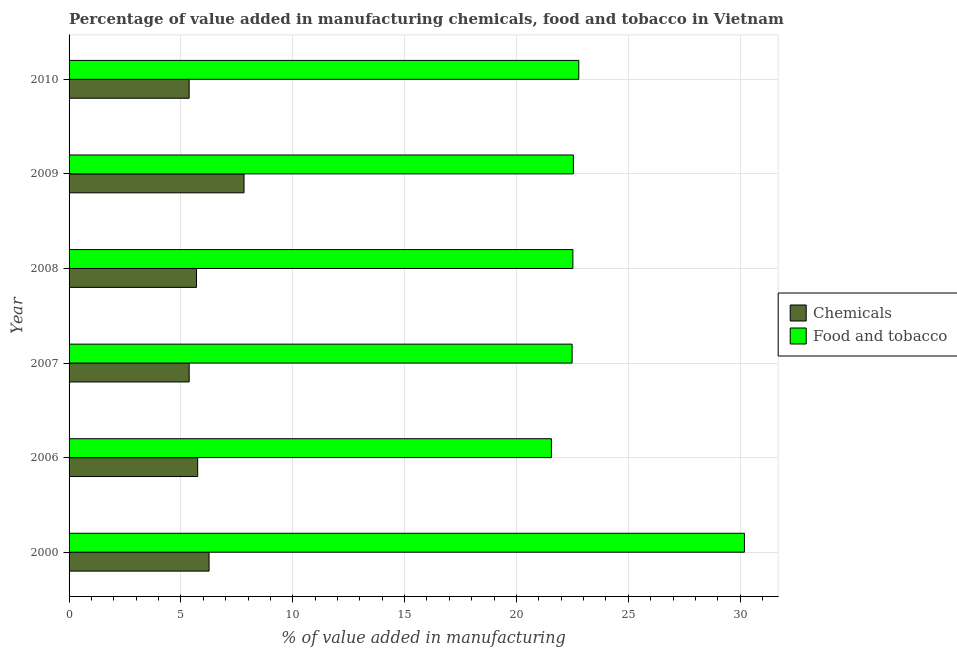Are the number of bars per tick equal to the number of legend labels?
Keep it short and to the point. Yes. Are the number of bars on each tick of the Y-axis equal?
Provide a short and direct response. Yes. What is the value added by  manufacturing chemicals in 2007?
Offer a very short reply. 5.37. Across all years, what is the maximum value added by manufacturing food and tobacco?
Provide a succinct answer. 30.19. Across all years, what is the minimum value added by manufacturing food and tobacco?
Your response must be concise. 21.56. What is the total value added by  manufacturing chemicals in the graph?
Provide a succinct answer. 36.26. What is the difference between the value added by manufacturing food and tobacco in 2007 and that in 2009?
Give a very brief answer. -0.06. What is the difference between the value added by manufacturing food and tobacco in 2009 and the value added by  manufacturing chemicals in 2000?
Your response must be concise. 16.29. What is the average value added by  manufacturing chemicals per year?
Offer a very short reply. 6.04. In the year 2000, what is the difference between the value added by  manufacturing chemicals and value added by manufacturing food and tobacco?
Provide a short and direct response. -23.93. What is the difference between the highest and the second highest value added by manufacturing food and tobacco?
Your answer should be compact. 7.41. What is the difference between the highest and the lowest value added by manufacturing food and tobacco?
Give a very brief answer. 8.63. In how many years, is the value added by manufacturing food and tobacco greater than the average value added by manufacturing food and tobacco taken over all years?
Your response must be concise. 1. Is the sum of the value added by  manufacturing chemicals in 2000 and 2006 greater than the maximum value added by manufacturing food and tobacco across all years?
Your answer should be compact. No. What does the 1st bar from the top in 2006 represents?
Keep it short and to the point. Food and tobacco. What does the 1st bar from the bottom in 2000 represents?
Make the answer very short. Chemicals. How many bars are there?
Make the answer very short. 12. Are all the bars in the graph horizontal?
Your answer should be compact. Yes. What is the difference between two consecutive major ticks on the X-axis?
Your answer should be very brief. 5. Does the graph contain grids?
Offer a terse response. Yes. What is the title of the graph?
Provide a short and direct response. Percentage of value added in manufacturing chemicals, food and tobacco in Vietnam. Does "Females" appear as one of the legend labels in the graph?
Your response must be concise. No. What is the label or title of the X-axis?
Make the answer very short. % of value added in manufacturing. What is the label or title of the Y-axis?
Give a very brief answer. Year. What is the % of value added in manufacturing in Chemicals in 2000?
Your response must be concise. 6.26. What is the % of value added in manufacturing of Food and tobacco in 2000?
Offer a very short reply. 30.19. What is the % of value added in manufacturing of Chemicals in 2006?
Offer a terse response. 5.75. What is the % of value added in manufacturing of Food and tobacco in 2006?
Provide a succinct answer. 21.56. What is the % of value added in manufacturing of Chemicals in 2007?
Your answer should be very brief. 5.37. What is the % of value added in manufacturing of Food and tobacco in 2007?
Give a very brief answer. 22.49. What is the % of value added in manufacturing in Chemicals in 2008?
Keep it short and to the point. 5.7. What is the % of value added in manufacturing in Food and tobacco in 2008?
Offer a terse response. 22.52. What is the % of value added in manufacturing in Chemicals in 2009?
Your response must be concise. 7.82. What is the % of value added in manufacturing in Food and tobacco in 2009?
Give a very brief answer. 22.55. What is the % of value added in manufacturing in Chemicals in 2010?
Offer a very short reply. 5.37. What is the % of value added in manufacturing of Food and tobacco in 2010?
Give a very brief answer. 22.79. Across all years, what is the maximum % of value added in manufacturing of Chemicals?
Provide a succinct answer. 7.82. Across all years, what is the maximum % of value added in manufacturing in Food and tobacco?
Ensure brevity in your answer.  30.19. Across all years, what is the minimum % of value added in manufacturing of Chemicals?
Your answer should be very brief. 5.37. Across all years, what is the minimum % of value added in manufacturing in Food and tobacco?
Offer a terse response. 21.56. What is the total % of value added in manufacturing in Chemicals in the graph?
Provide a short and direct response. 36.26. What is the total % of value added in manufacturing of Food and tobacco in the graph?
Keep it short and to the point. 142.1. What is the difference between the % of value added in manufacturing in Chemicals in 2000 and that in 2006?
Provide a short and direct response. 0.51. What is the difference between the % of value added in manufacturing in Food and tobacco in 2000 and that in 2006?
Your answer should be very brief. 8.63. What is the difference between the % of value added in manufacturing in Chemicals in 2000 and that in 2007?
Your answer should be compact. 0.89. What is the difference between the % of value added in manufacturing of Food and tobacco in 2000 and that in 2007?
Make the answer very short. 7.7. What is the difference between the % of value added in manufacturing of Chemicals in 2000 and that in 2008?
Keep it short and to the point. 0.56. What is the difference between the % of value added in manufacturing of Food and tobacco in 2000 and that in 2008?
Your answer should be compact. 7.67. What is the difference between the % of value added in manufacturing in Chemicals in 2000 and that in 2009?
Your answer should be compact. -1.56. What is the difference between the % of value added in manufacturing of Food and tobacco in 2000 and that in 2009?
Offer a very short reply. 7.65. What is the difference between the % of value added in manufacturing in Chemicals in 2000 and that in 2010?
Offer a very short reply. 0.89. What is the difference between the % of value added in manufacturing of Food and tobacco in 2000 and that in 2010?
Keep it short and to the point. 7.41. What is the difference between the % of value added in manufacturing of Chemicals in 2006 and that in 2007?
Offer a very short reply. 0.38. What is the difference between the % of value added in manufacturing of Food and tobacco in 2006 and that in 2007?
Make the answer very short. -0.93. What is the difference between the % of value added in manufacturing in Chemicals in 2006 and that in 2008?
Provide a short and direct response. 0.05. What is the difference between the % of value added in manufacturing of Food and tobacco in 2006 and that in 2008?
Give a very brief answer. -0.96. What is the difference between the % of value added in manufacturing of Chemicals in 2006 and that in 2009?
Ensure brevity in your answer.  -2.07. What is the difference between the % of value added in manufacturing of Food and tobacco in 2006 and that in 2009?
Keep it short and to the point. -0.98. What is the difference between the % of value added in manufacturing in Chemicals in 2006 and that in 2010?
Provide a succinct answer. 0.38. What is the difference between the % of value added in manufacturing in Food and tobacco in 2006 and that in 2010?
Keep it short and to the point. -1.22. What is the difference between the % of value added in manufacturing of Chemicals in 2007 and that in 2008?
Ensure brevity in your answer.  -0.33. What is the difference between the % of value added in manufacturing of Food and tobacco in 2007 and that in 2008?
Give a very brief answer. -0.03. What is the difference between the % of value added in manufacturing in Chemicals in 2007 and that in 2009?
Give a very brief answer. -2.45. What is the difference between the % of value added in manufacturing in Food and tobacco in 2007 and that in 2009?
Provide a succinct answer. -0.06. What is the difference between the % of value added in manufacturing in Chemicals in 2007 and that in 2010?
Give a very brief answer. 0. What is the difference between the % of value added in manufacturing of Food and tobacco in 2007 and that in 2010?
Offer a very short reply. -0.3. What is the difference between the % of value added in manufacturing in Chemicals in 2008 and that in 2009?
Ensure brevity in your answer.  -2.13. What is the difference between the % of value added in manufacturing of Food and tobacco in 2008 and that in 2009?
Your response must be concise. -0.02. What is the difference between the % of value added in manufacturing of Chemicals in 2008 and that in 2010?
Your answer should be compact. 0.33. What is the difference between the % of value added in manufacturing of Food and tobacco in 2008 and that in 2010?
Make the answer very short. -0.26. What is the difference between the % of value added in manufacturing of Chemicals in 2009 and that in 2010?
Give a very brief answer. 2.45. What is the difference between the % of value added in manufacturing of Food and tobacco in 2009 and that in 2010?
Your answer should be very brief. -0.24. What is the difference between the % of value added in manufacturing in Chemicals in 2000 and the % of value added in manufacturing in Food and tobacco in 2006?
Your response must be concise. -15.31. What is the difference between the % of value added in manufacturing of Chemicals in 2000 and the % of value added in manufacturing of Food and tobacco in 2007?
Offer a very short reply. -16.23. What is the difference between the % of value added in manufacturing of Chemicals in 2000 and the % of value added in manufacturing of Food and tobacco in 2008?
Your answer should be very brief. -16.27. What is the difference between the % of value added in manufacturing of Chemicals in 2000 and the % of value added in manufacturing of Food and tobacco in 2009?
Make the answer very short. -16.29. What is the difference between the % of value added in manufacturing of Chemicals in 2000 and the % of value added in manufacturing of Food and tobacco in 2010?
Provide a short and direct response. -16.53. What is the difference between the % of value added in manufacturing of Chemicals in 2006 and the % of value added in manufacturing of Food and tobacco in 2007?
Provide a short and direct response. -16.74. What is the difference between the % of value added in manufacturing in Chemicals in 2006 and the % of value added in manufacturing in Food and tobacco in 2008?
Offer a very short reply. -16.77. What is the difference between the % of value added in manufacturing in Chemicals in 2006 and the % of value added in manufacturing in Food and tobacco in 2009?
Make the answer very short. -16.8. What is the difference between the % of value added in manufacturing of Chemicals in 2006 and the % of value added in manufacturing of Food and tobacco in 2010?
Provide a short and direct response. -17.04. What is the difference between the % of value added in manufacturing in Chemicals in 2007 and the % of value added in manufacturing in Food and tobacco in 2008?
Provide a succinct answer. -17.15. What is the difference between the % of value added in manufacturing of Chemicals in 2007 and the % of value added in manufacturing of Food and tobacco in 2009?
Your answer should be compact. -17.18. What is the difference between the % of value added in manufacturing in Chemicals in 2007 and the % of value added in manufacturing in Food and tobacco in 2010?
Offer a terse response. -17.42. What is the difference between the % of value added in manufacturing in Chemicals in 2008 and the % of value added in manufacturing in Food and tobacco in 2009?
Your response must be concise. -16.85. What is the difference between the % of value added in manufacturing of Chemicals in 2008 and the % of value added in manufacturing of Food and tobacco in 2010?
Offer a very short reply. -17.09. What is the difference between the % of value added in manufacturing in Chemicals in 2009 and the % of value added in manufacturing in Food and tobacco in 2010?
Ensure brevity in your answer.  -14.97. What is the average % of value added in manufacturing in Chemicals per year?
Provide a short and direct response. 6.04. What is the average % of value added in manufacturing of Food and tobacco per year?
Your answer should be very brief. 23.68. In the year 2000, what is the difference between the % of value added in manufacturing of Chemicals and % of value added in manufacturing of Food and tobacco?
Offer a terse response. -23.93. In the year 2006, what is the difference between the % of value added in manufacturing of Chemicals and % of value added in manufacturing of Food and tobacco?
Your answer should be compact. -15.81. In the year 2007, what is the difference between the % of value added in manufacturing of Chemicals and % of value added in manufacturing of Food and tobacco?
Your answer should be compact. -17.12. In the year 2008, what is the difference between the % of value added in manufacturing in Chemicals and % of value added in manufacturing in Food and tobacco?
Keep it short and to the point. -16.83. In the year 2009, what is the difference between the % of value added in manufacturing in Chemicals and % of value added in manufacturing in Food and tobacco?
Provide a succinct answer. -14.72. In the year 2010, what is the difference between the % of value added in manufacturing of Chemicals and % of value added in manufacturing of Food and tobacco?
Ensure brevity in your answer.  -17.42. What is the ratio of the % of value added in manufacturing of Chemicals in 2000 to that in 2006?
Provide a succinct answer. 1.09. What is the ratio of the % of value added in manufacturing in Food and tobacco in 2000 to that in 2006?
Give a very brief answer. 1.4. What is the ratio of the % of value added in manufacturing of Chemicals in 2000 to that in 2007?
Your response must be concise. 1.17. What is the ratio of the % of value added in manufacturing of Food and tobacco in 2000 to that in 2007?
Make the answer very short. 1.34. What is the ratio of the % of value added in manufacturing of Chemicals in 2000 to that in 2008?
Your response must be concise. 1.1. What is the ratio of the % of value added in manufacturing in Food and tobacco in 2000 to that in 2008?
Provide a short and direct response. 1.34. What is the ratio of the % of value added in manufacturing in Chemicals in 2000 to that in 2009?
Make the answer very short. 0.8. What is the ratio of the % of value added in manufacturing of Food and tobacco in 2000 to that in 2009?
Offer a very short reply. 1.34. What is the ratio of the % of value added in manufacturing of Chemicals in 2000 to that in 2010?
Give a very brief answer. 1.17. What is the ratio of the % of value added in manufacturing in Food and tobacco in 2000 to that in 2010?
Your response must be concise. 1.32. What is the ratio of the % of value added in manufacturing in Chemicals in 2006 to that in 2007?
Ensure brevity in your answer.  1.07. What is the ratio of the % of value added in manufacturing in Food and tobacco in 2006 to that in 2007?
Your answer should be compact. 0.96. What is the ratio of the % of value added in manufacturing in Chemicals in 2006 to that in 2008?
Provide a succinct answer. 1.01. What is the ratio of the % of value added in manufacturing in Food and tobacco in 2006 to that in 2008?
Offer a very short reply. 0.96. What is the ratio of the % of value added in manufacturing in Chemicals in 2006 to that in 2009?
Keep it short and to the point. 0.73. What is the ratio of the % of value added in manufacturing of Food and tobacco in 2006 to that in 2009?
Provide a succinct answer. 0.96. What is the ratio of the % of value added in manufacturing of Chemicals in 2006 to that in 2010?
Offer a very short reply. 1.07. What is the ratio of the % of value added in manufacturing in Food and tobacco in 2006 to that in 2010?
Give a very brief answer. 0.95. What is the ratio of the % of value added in manufacturing of Chemicals in 2007 to that in 2008?
Your answer should be very brief. 0.94. What is the ratio of the % of value added in manufacturing of Chemicals in 2007 to that in 2009?
Your response must be concise. 0.69. What is the ratio of the % of value added in manufacturing of Food and tobacco in 2007 to that in 2009?
Provide a succinct answer. 1. What is the ratio of the % of value added in manufacturing in Food and tobacco in 2007 to that in 2010?
Your answer should be very brief. 0.99. What is the ratio of the % of value added in manufacturing in Chemicals in 2008 to that in 2009?
Make the answer very short. 0.73. What is the ratio of the % of value added in manufacturing of Food and tobacco in 2008 to that in 2009?
Your answer should be compact. 1. What is the ratio of the % of value added in manufacturing in Chemicals in 2008 to that in 2010?
Your response must be concise. 1.06. What is the ratio of the % of value added in manufacturing in Food and tobacco in 2008 to that in 2010?
Offer a very short reply. 0.99. What is the ratio of the % of value added in manufacturing in Chemicals in 2009 to that in 2010?
Your response must be concise. 1.46. What is the ratio of the % of value added in manufacturing in Food and tobacco in 2009 to that in 2010?
Your answer should be very brief. 0.99. What is the difference between the highest and the second highest % of value added in manufacturing of Chemicals?
Give a very brief answer. 1.56. What is the difference between the highest and the second highest % of value added in manufacturing of Food and tobacco?
Provide a short and direct response. 7.41. What is the difference between the highest and the lowest % of value added in manufacturing of Chemicals?
Make the answer very short. 2.45. What is the difference between the highest and the lowest % of value added in manufacturing in Food and tobacco?
Your answer should be very brief. 8.63. 